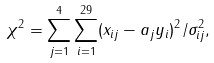Convert formula to latex. <formula><loc_0><loc_0><loc_500><loc_500>\chi ^ { 2 } = \sum ^ { 4 } _ { j = 1 } \sum ^ { 2 9 } _ { i = 1 } ( x _ { i j } - a _ { j } y _ { i } ) ^ { 2 } / \sigma ^ { 2 } _ { i j } ,</formula> 